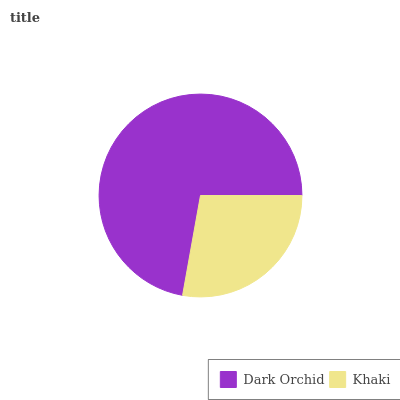Is Khaki the minimum?
Answer yes or no. Yes. Is Dark Orchid the maximum?
Answer yes or no. Yes. Is Khaki the maximum?
Answer yes or no. No. Is Dark Orchid greater than Khaki?
Answer yes or no. Yes. Is Khaki less than Dark Orchid?
Answer yes or no. Yes. Is Khaki greater than Dark Orchid?
Answer yes or no. No. Is Dark Orchid less than Khaki?
Answer yes or no. No. Is Dark Orchid the high median?
Answer yes or no. Yes. Is Khaki the low median?
Answer yes or no. Yes. Is Khaki the high median?
Answer yes or no. No. Is Dark Orchid the low median?
Answer yes or no. No. 